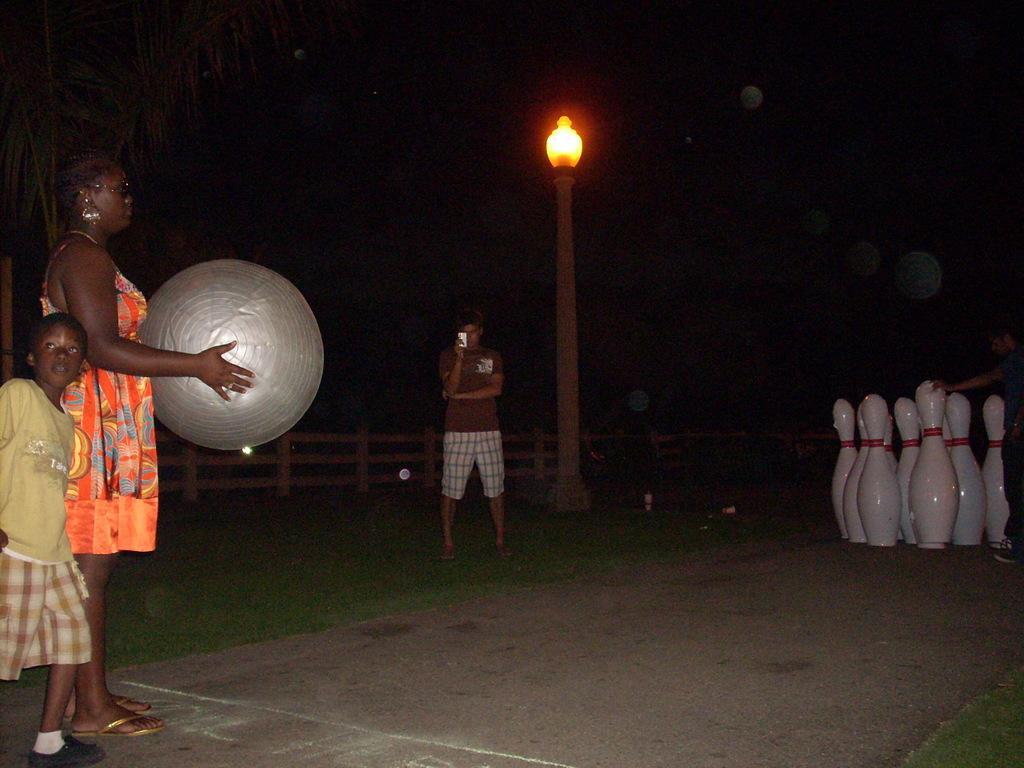How would you summarize this image in a sentence or two? There is a woman holding a musical instrument. Near to her there is a boy. In the back there is a person. On the right side there are some white color objects. Also there is a light pole in the back. And there is a railing in the background. 